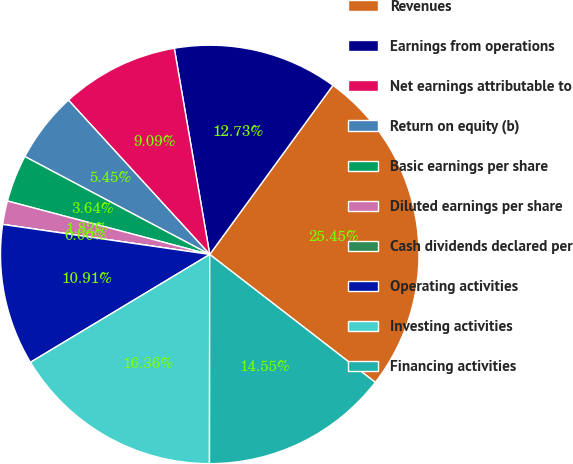Convert chart to OTSL. <chart><loc_0><loc_0><loc_500><loc_500><pie_chart><fcel>Revenues<fcel>Earnings from operations<fcel>Net earnings attributable to<fcel>Return on equity (b)<fcel>Basic earnings per share<fcel>Diluted earnings per share<fcel>Cash dividends declared per<fcel>Operating activities<fcel>Investing activities<fcel>Financing activities<nl><fcel>25.45%<fcel>12.73%<fcel>9.09%<fcel>5.45%<fcel>3.64%<fcel>1.82%<fcel>0.0%<fcel>10.91%<fcel>16.36%<fcel>14.55%<nl></chart> 